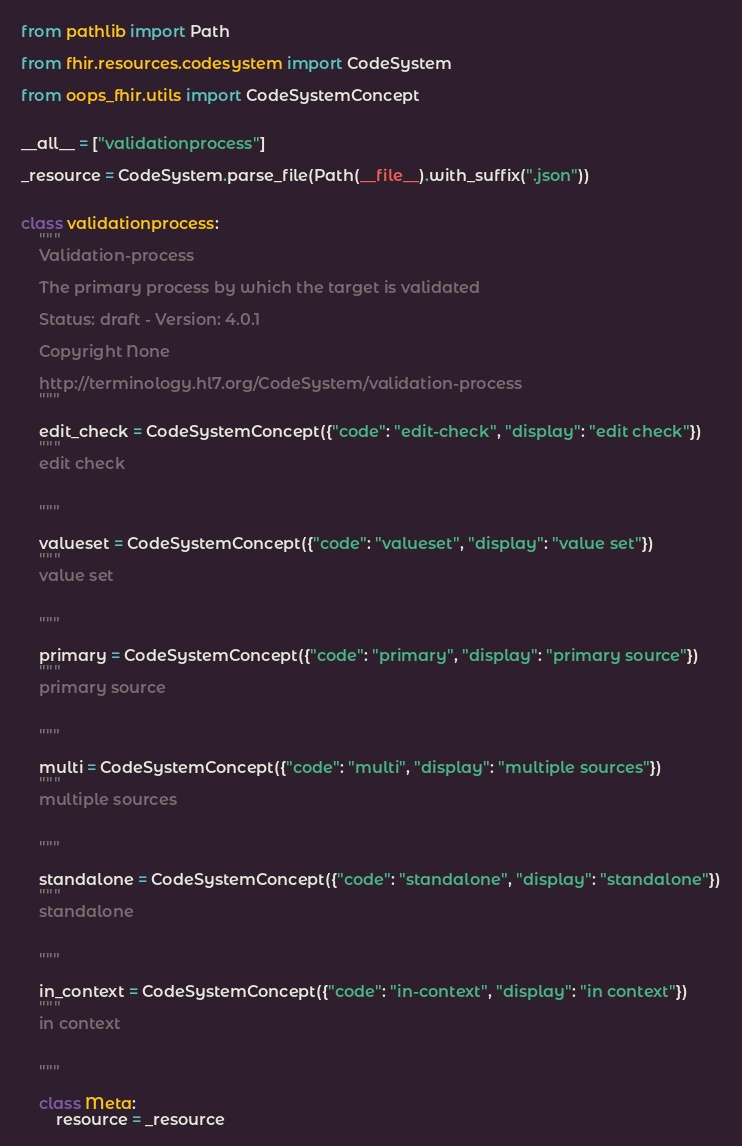<code> <loc_0><loc_0><loc_500><loc_500><_Python_>from pathlib import Path

from fhir.resources.codesystem import CodeSystem

from oops_fhir.utils import CodeSystemConcept


__all__ = ["validationprocess"]

_resource = CodeSystem.parse_file(Path(__file__).with_suffix(".json"))


class validationprocess:
    """
    Validation-process

    The primary process by which the target is validated

    Status: draft - Version: 4.0.1

    Copyright None

    http://terminology.hl7.org/CodeSystem/validation-process
    """

    edit_check = CodeSystemConcept({"code": "edit-check", "display": "edit check"})
    """
    edit check

    
    """

    valueset = CodeSystemConcept({"code": "valueset", "display": "value set"})
    """
    value set

    
    """

    primary = CodeSystemConcept({"code": "primary", "display": "primary source"})
    """
    primary source

    
    """

    multi = CodeSystemConcept({"code": "multi", "display": "multiple sources"})
    """
    multiple sources

    
    """

    standalone = CodeSystemConcept({"code": "standalone", "display": "standalone"})
    """
    standalone

    
    """

    in_context = CodeSystemConcept({"code": "in-context", "display": "in context"})
    """
    in context

    
    """

    class Meta:
        resource = _resource
</code> 